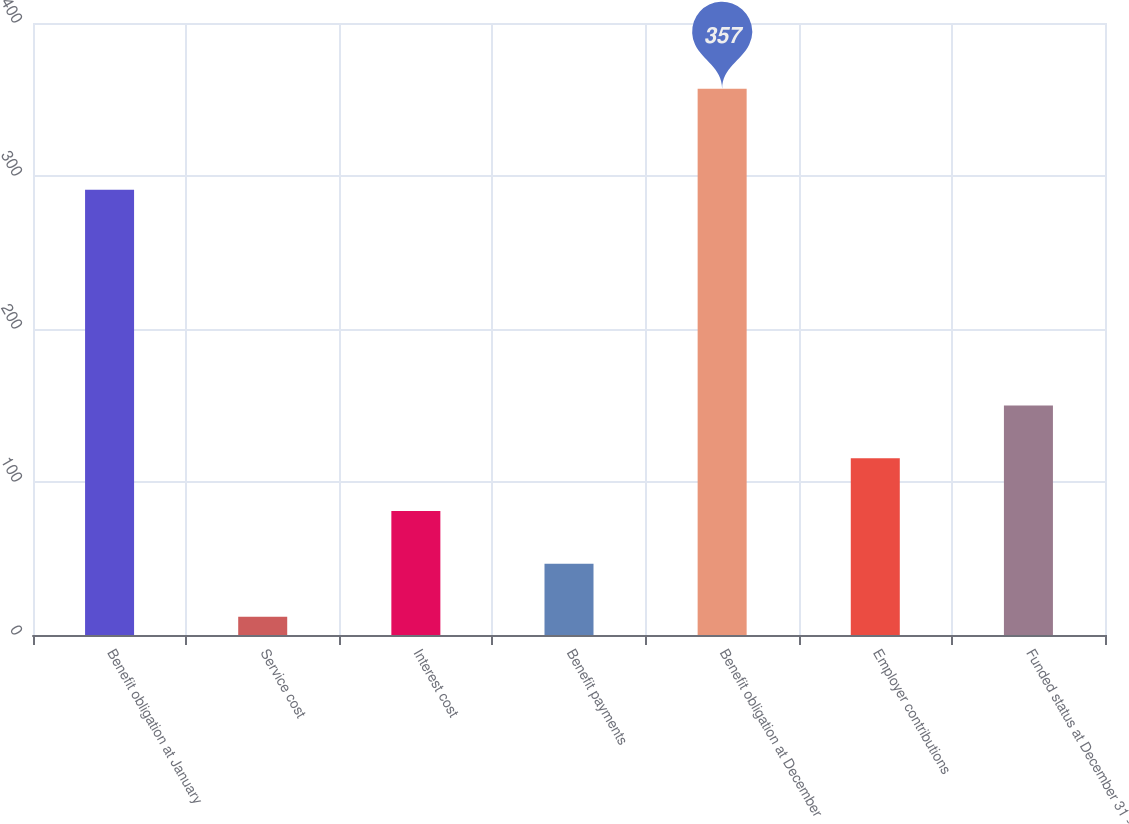Convert chart. <chart><loc_0><loc_0><loc_500><loc_500><bar_chart><fcel>Benefit obligation at January<fcel>Service cost<fcel>Interest cost<fcel>Benefit payments<fcel>Benefit obligation at December<fcel>Employer contributions<fcel>Funded status at December 31 -<nl><fcel>291<fcel>12<fcel>81<fcel>46.5<fcel>357<fcel>115.5<fcel>150<nl></chart> 